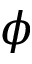<formula> <loc_0><loc_0><loc_500><loc_500>\phi</formula> 